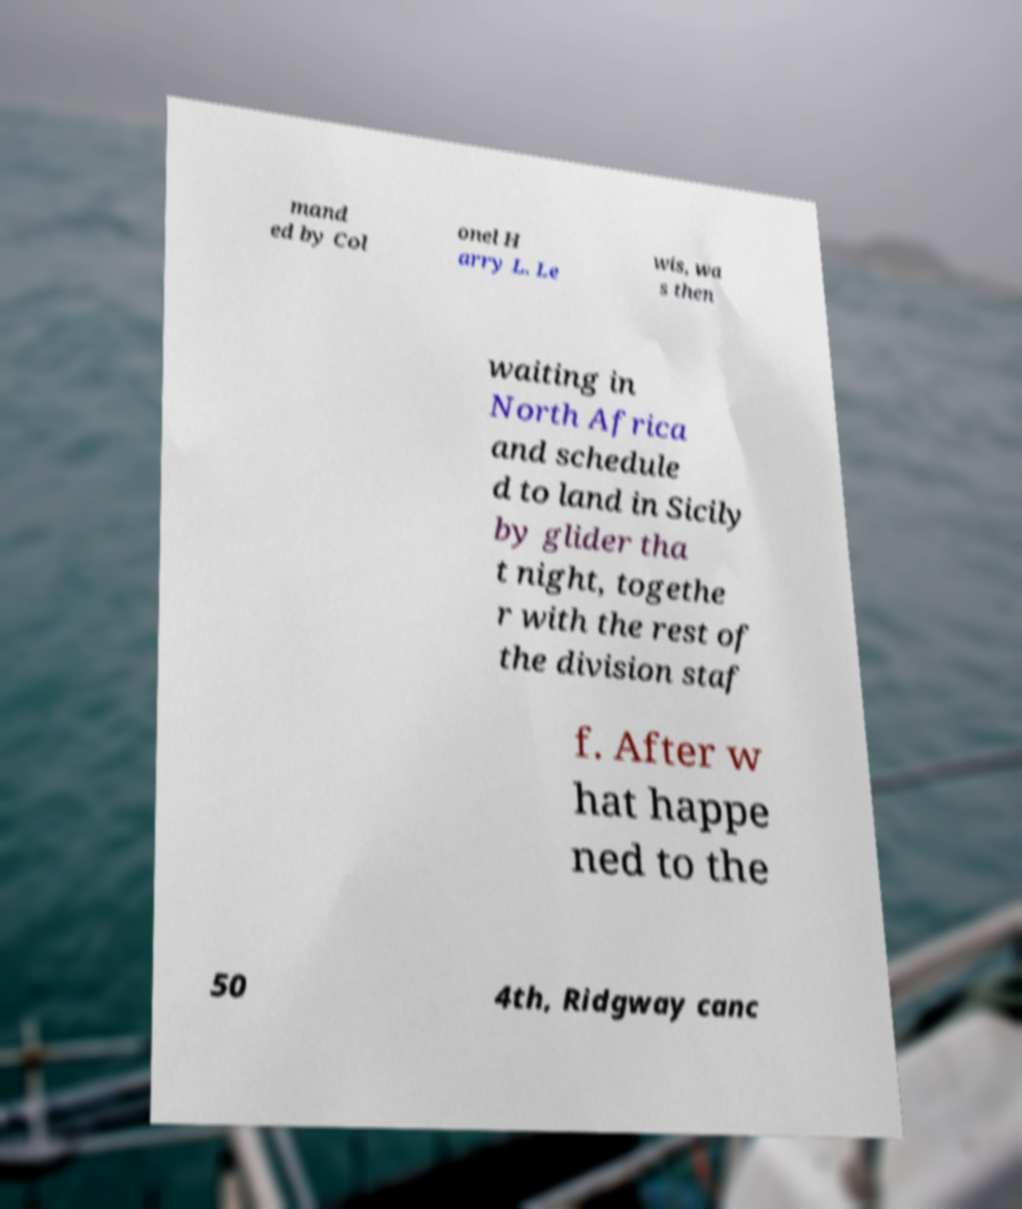Can you read and provide the text displayed in the image?This photo seems to have some interesting text. Can you extract and type it out for me? mand ed by Col onel H arry L. Le wis, wa s then waiting in North Africa and schedule d to land in Sicily by glider tha t night, togethe r with the rest of the division staf f. After w hat happe ned to the 50 4th, Ridgway canc 